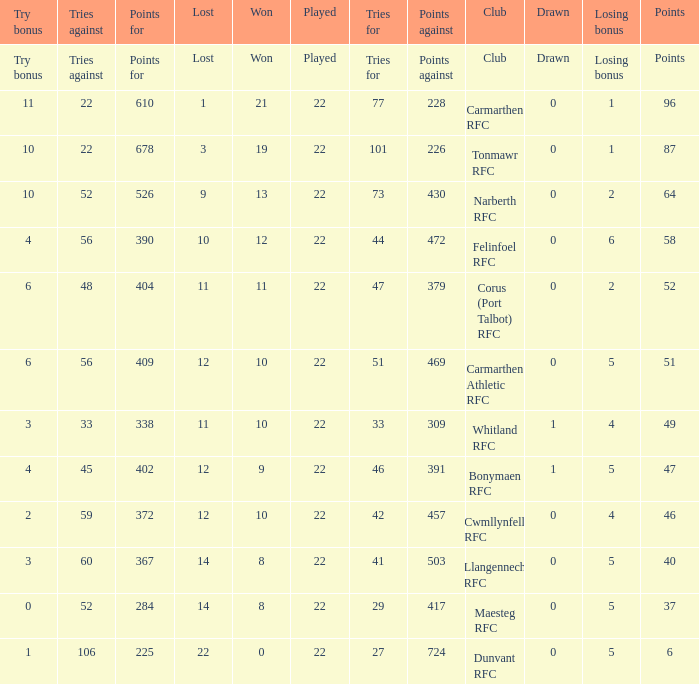Name the tries against for 87 points 22.0. 